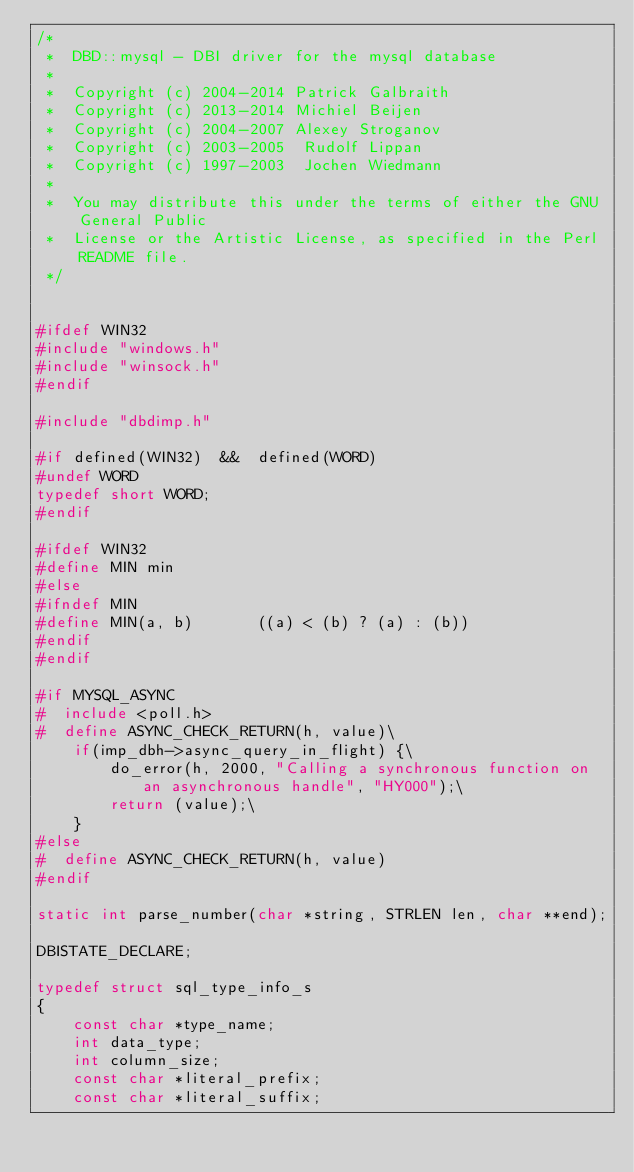<code> <loc_0><loc_0><loc_500><loc_500><_C_>/*
 *  DBD::mysql - DBI driver for the mysql database
 *
 *  Copyright (c) 2004-2014 Patrick Galbraith
 *  Copyright (c) 2013-2014 Michiel Beijen 
 *  Copyright (c) 2004-2007 Alexey Stroganov 
 *  Copyright (c) 2003-2005  Rudolf Lippan
 *  Copyright (c) 1997-2003  Jochen Wiedmann
 *
 *  You may distribute this under the terms of either the GNU General Public
 *  License or the Artistic License, as specified in the Perl README file.
 */


#ifdef WIN32
#include "windows.h"
#include "winsock.h"
#endif

#include "dbdimp.h"

#if defined(WIN32)  &&  defined(WORD)
#undef WORD
typedef short WORD;
#endif

#ifdef WIN32
#define MIN min
#else
#ifndef MIN
#define MIN(a, b)       ((a) < (b) ? (a) : (b))
#endif
#endif

#if MYSQL_ASYNC
#  include <poll.h>
#  define ASYNC_CHECK_RETURN(h, value)\
    if(imp_dbh->async_query_in_flight) {\
        do_error(h, 2000, "Calling a synchronous function on an asynchronous handle", "HY000");\
        return (value);\
    }
#else
#  define ASYNC_CHECK_RETURN(h, value)
#endif

static int parse_number(char *string, STRLEN len, char **end);

DBISTATE_DECLARE;

typedef struct sql_type_info_s
{
    const char *type_name;
    int data_type;
    int column_size;
    const char *literal_prefix;
    const char *literal_suffix;</code> 